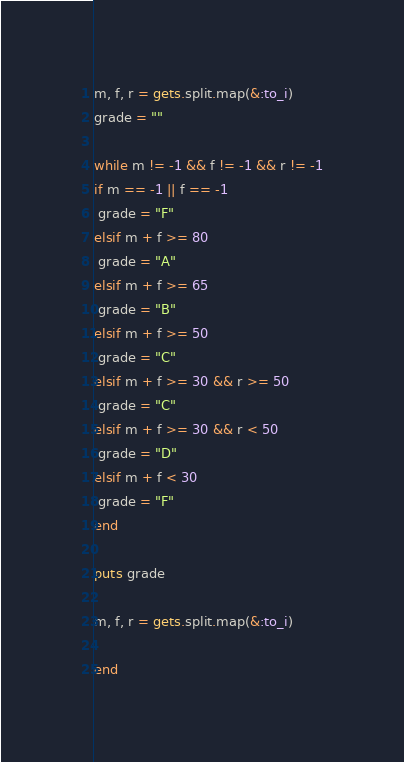Convert code to text. <code><loc_0><loc_0><loc_500><loc_500><_Ruby_>m, f, r = gets.split.map(&:to_i)
grade = ""

while m != -1 && f != -1 && r != -1
if m == -1 || f == -1
 grade = "F"
elsif m + f >= 80
 grade = "A"
elsif m + f >= 65
 grade = "B"
elsif m + f >= 50
 grade = "C"
elsif m + f >= 30 && r >= 50
 grade = "C"
elsif m + f >= 30 && r < 50
 grade = "D"
elsif m + f < 30
 grade = "F"
end

puts grade

m, f, r = gets.split.map(&:to_i)

end

</code> 